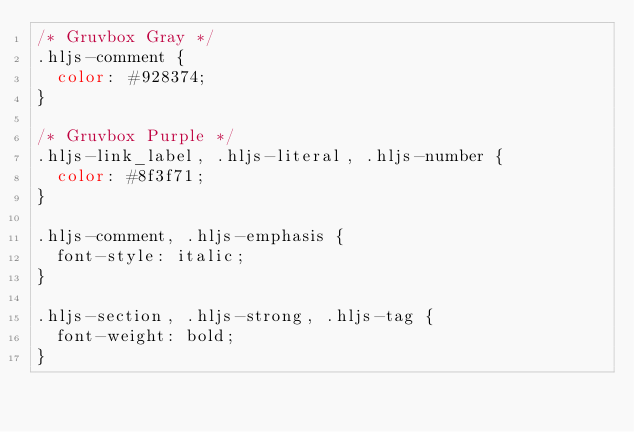<code> <loc_0><loc_0><loc_500><loc_500><_CSS_>/* Gruvbox Gray */
.hljs-comment {
  color: #928374;
}

/* Gruvbox Purple */
.hljs-link_label, .hljs-literal, .hljs-number {
  color: #8f3f71;
}

.hljs-comment, .hljs-emphasis {
  font-style: italic;
}

.hljs-section, .hljs-strong, .hljs-tag {
  font-weight: bold;
}
</code> 